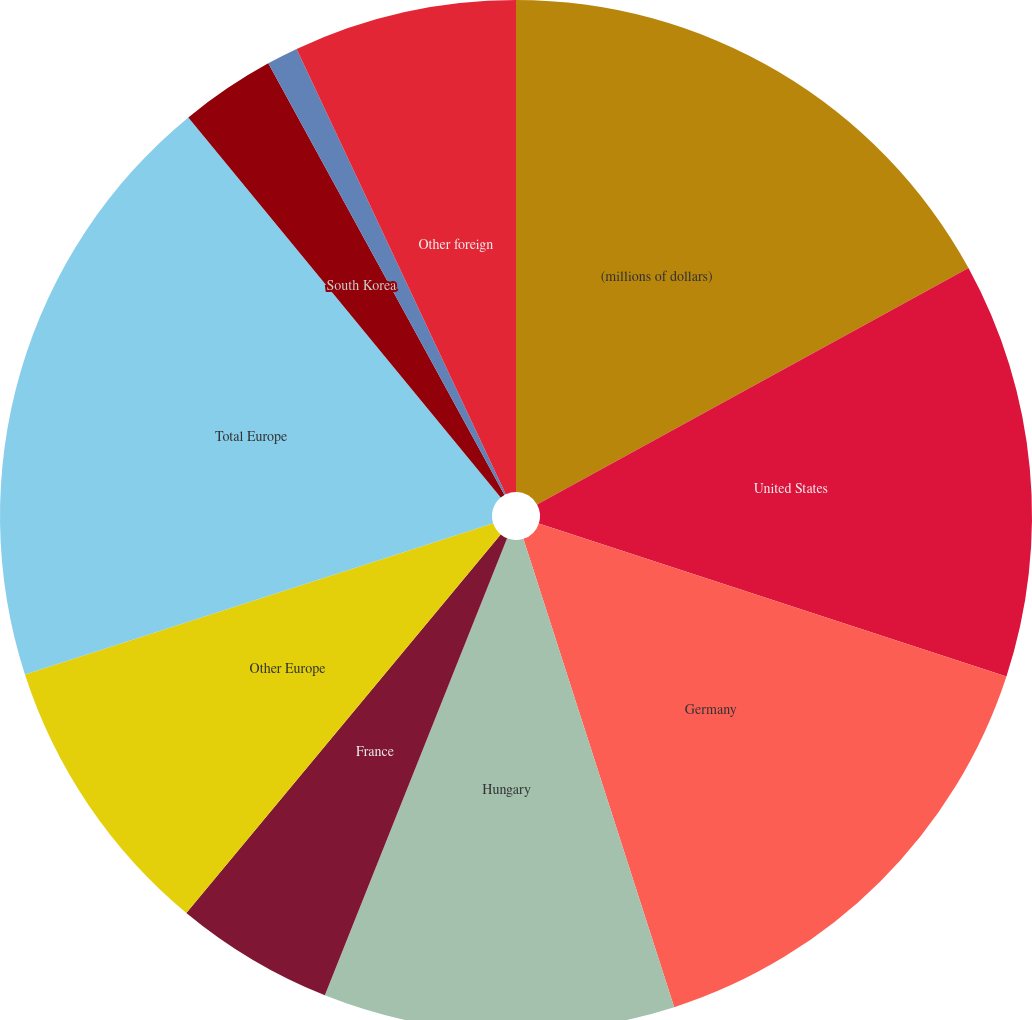Convert chart to OTSL. <chart><loc_0><loc_0><loc_500><loc_500><pie_chart><fcel>(millions of dollars)<fcel>United States<fcel>Germany<fcel>Hungary<fcel>France<fcel>Other Europe<fcel>Total Europe<fcel>South Korea<fcel>China<fcel>Other foreign<nl><fcel>17.02%<fcel>13.01%<fcel>15.01%<fcel>11.0%<fcel>4.99%<fcel>9.0%<fcel>19.02%<fcel>2.98%<fcel>0.98%<fcel>6.99%<nl></chart> 